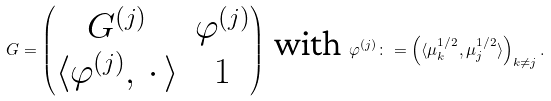<formula> <loc_0><loc_0><loc_500><loc_500>G = \begin{pmatrix} G ^ { ( j ) } & \varphi ^ { ( j ) } \\ \langle \varphi ^ { ( j ) } , \, \cdot \, \rangle & 1 \end{pmatrix} \text { with } \varphi ^ { ( j ) } \colon = \left ( \langle \mu _ { k } ^ { 1 / 2 } , \mu _ { j } ^ { 1 / 2 } \rangle \right ) _ { k \ne j } .</formula> 